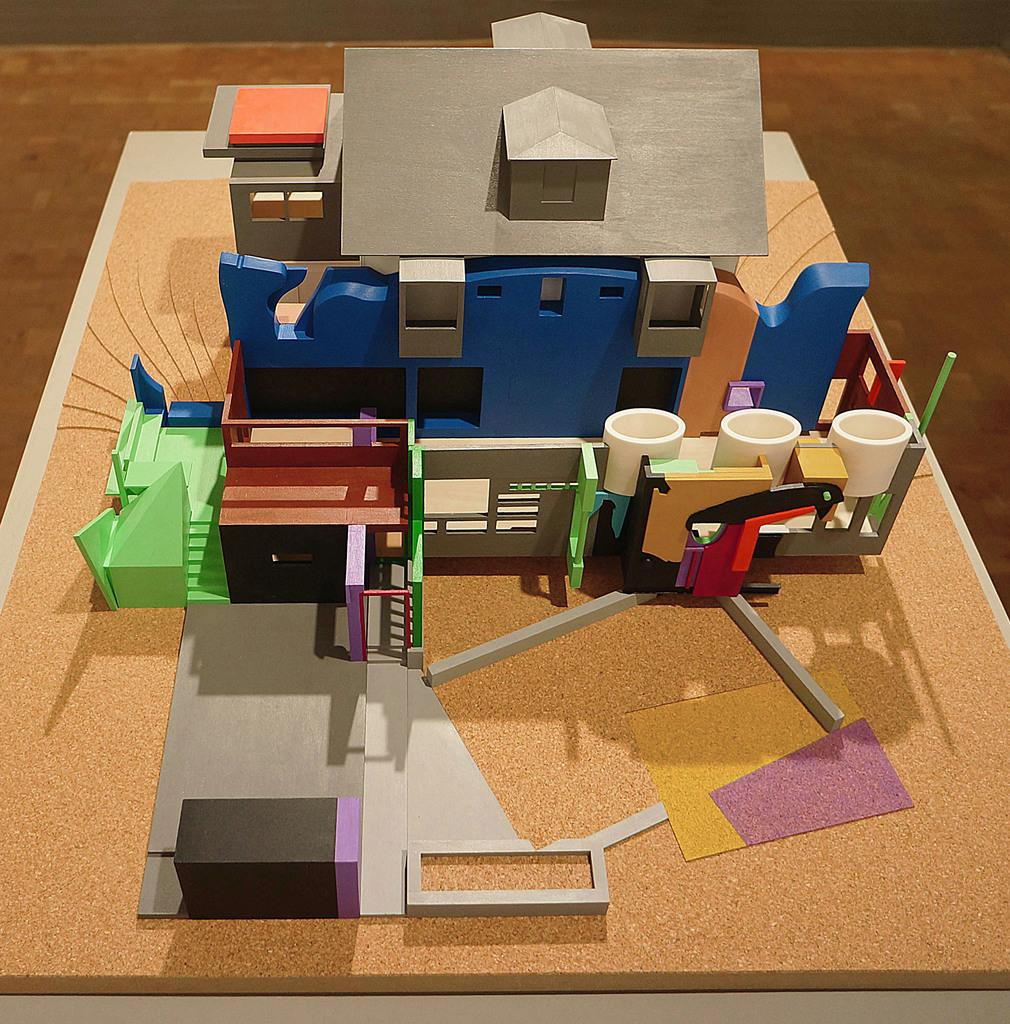What is located in the foreground of the image? There is a table in the foreground of the image. What is placed on the table? There is a fence and a house on the table. What type of image is this? The image appears to be an animated photo. What type of zipper can be seen on the house in the image? There is no zipper present on the house in the image. 